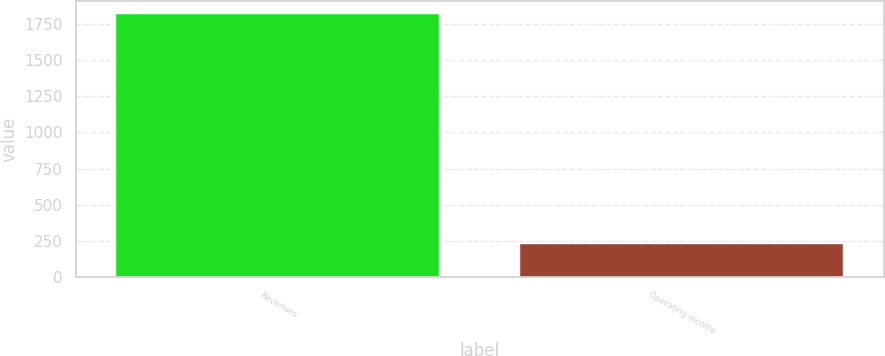Convert chart to OTSL. <chart><loc_0><loc_0><loc_500><loc_500><bar_chart><fcel>Revenues<fcel>Operating income<nl><fcel>1817<fcel>230<nl></chart> 